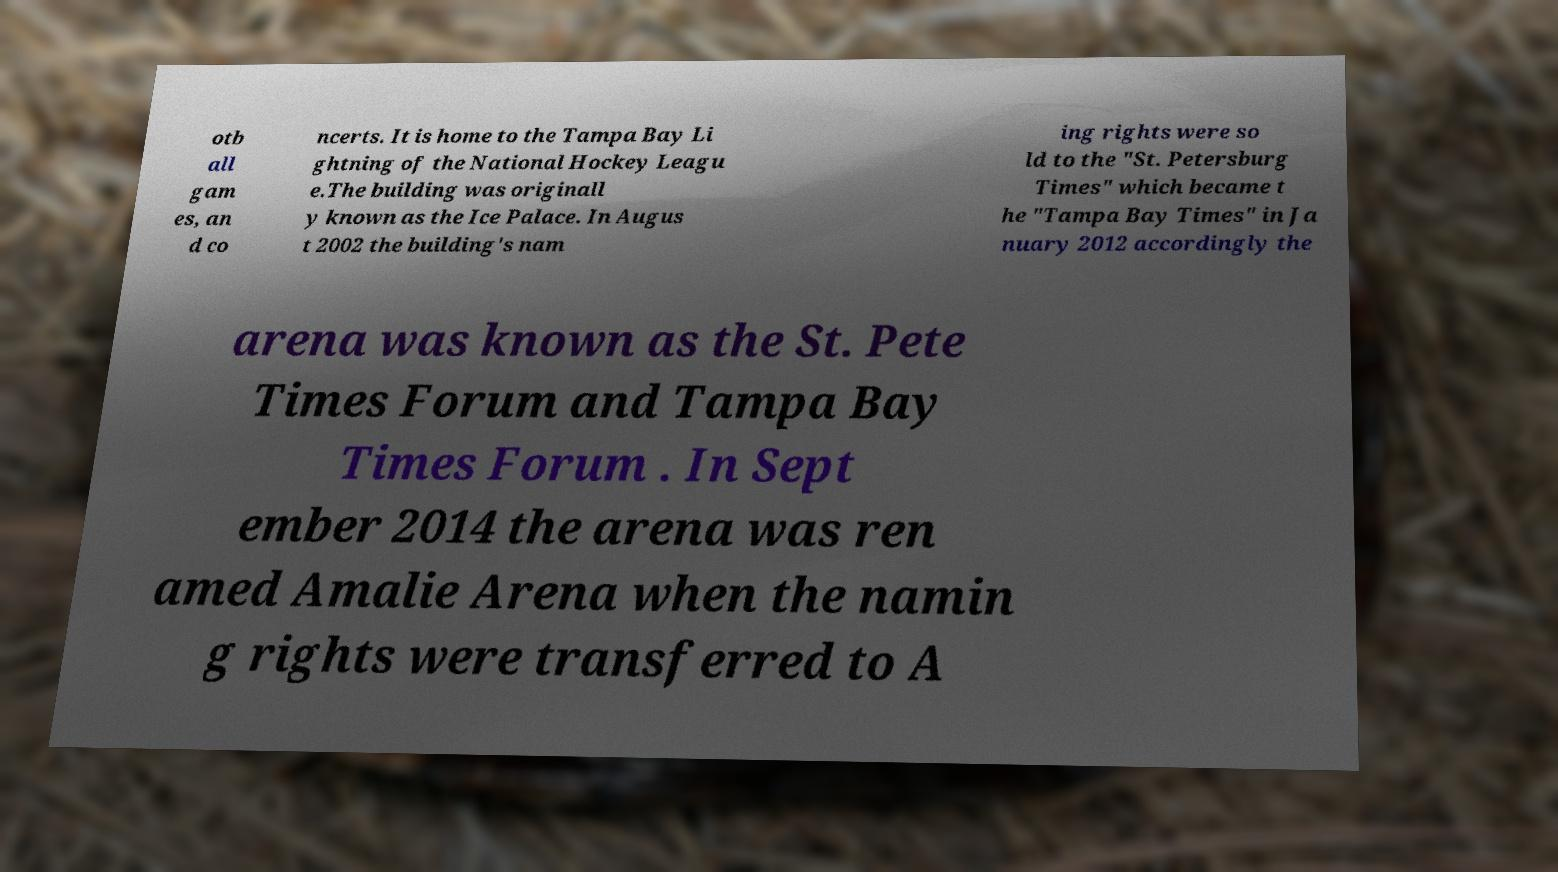Please identify and transcribe the text found in this image. otb all gam es, an d co ncerts. It is home to the Tampa Bay Li ghtning of the National Hockey Leagu e.The building was originall y known as the Ice Palace. In Augus t 2002 the building's nam ing rights were so ld to the "St. Petersburg Times" which became t he "Tampa Bay Times" in Ja nuary 2012 accordingly the arena was known as the St. Pete Times Forum and Tampa Bay Times Forum . In Sept ember 2014 the arena was ren amed Amalie Arena when the namin g rights were transferred to A 